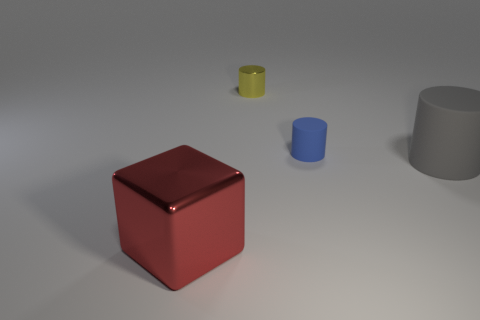Add 2 green metal cylinders. How many objects exist? 6 Subtract all cubes. How many objects are left? 3 Add 4 tiny brown things. How many tiny brown things exist? 4 Subtract 0 brown blocks. How many objects are left? 4 Subtract all big yellow things. Subtract all gray matte cylinders. How many objects are left? 3 Add 4 yellow cylinders. How many yellow cylinders are left? 5 